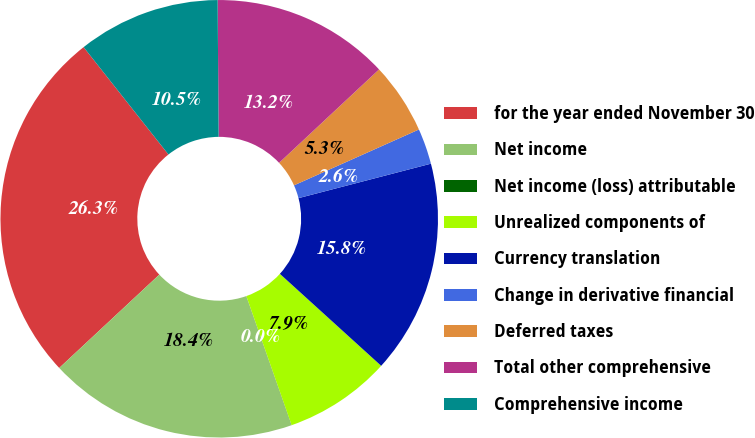<chart> <loc_0><loc_0><loc_500><loc_500><pie_chart><fcel>for the year ended November 30<fcel>Net income<fcel>Net income (loss) attributable<fcel>Unrealized components of<fcel>Currency translation<fcel>Change in derivative financial<fcel>Deferred taxes<fcel>Total other comprehensive<fcel>Comprehensive income<nl><fcel>26.31%<fcel>18.42%<fcel>0.01%<fcel>7.9%<fcel>15.79%<fcel>2.64%<fcel>5.27%<fcel>13.16%<fcel>10.53%<nl></chart> 